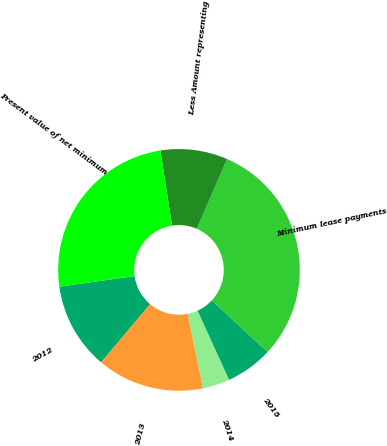Convert chart. <chart><loc_0><loc_0><loc_500><loc_500><pie_chart><fcel>2012<fcel>2013<fcel>2014<fcel>2015<fcel>Minimum lease payments<fcel>Less Amount representing<fcel>Present value of net minimum<nl><fcel>11.65%<fcel>14.32%<fcel>3.63%<fcel>6.3%<fcel>30.37%<fcel>8.97%<fcel>24.76%<nl></chart> 